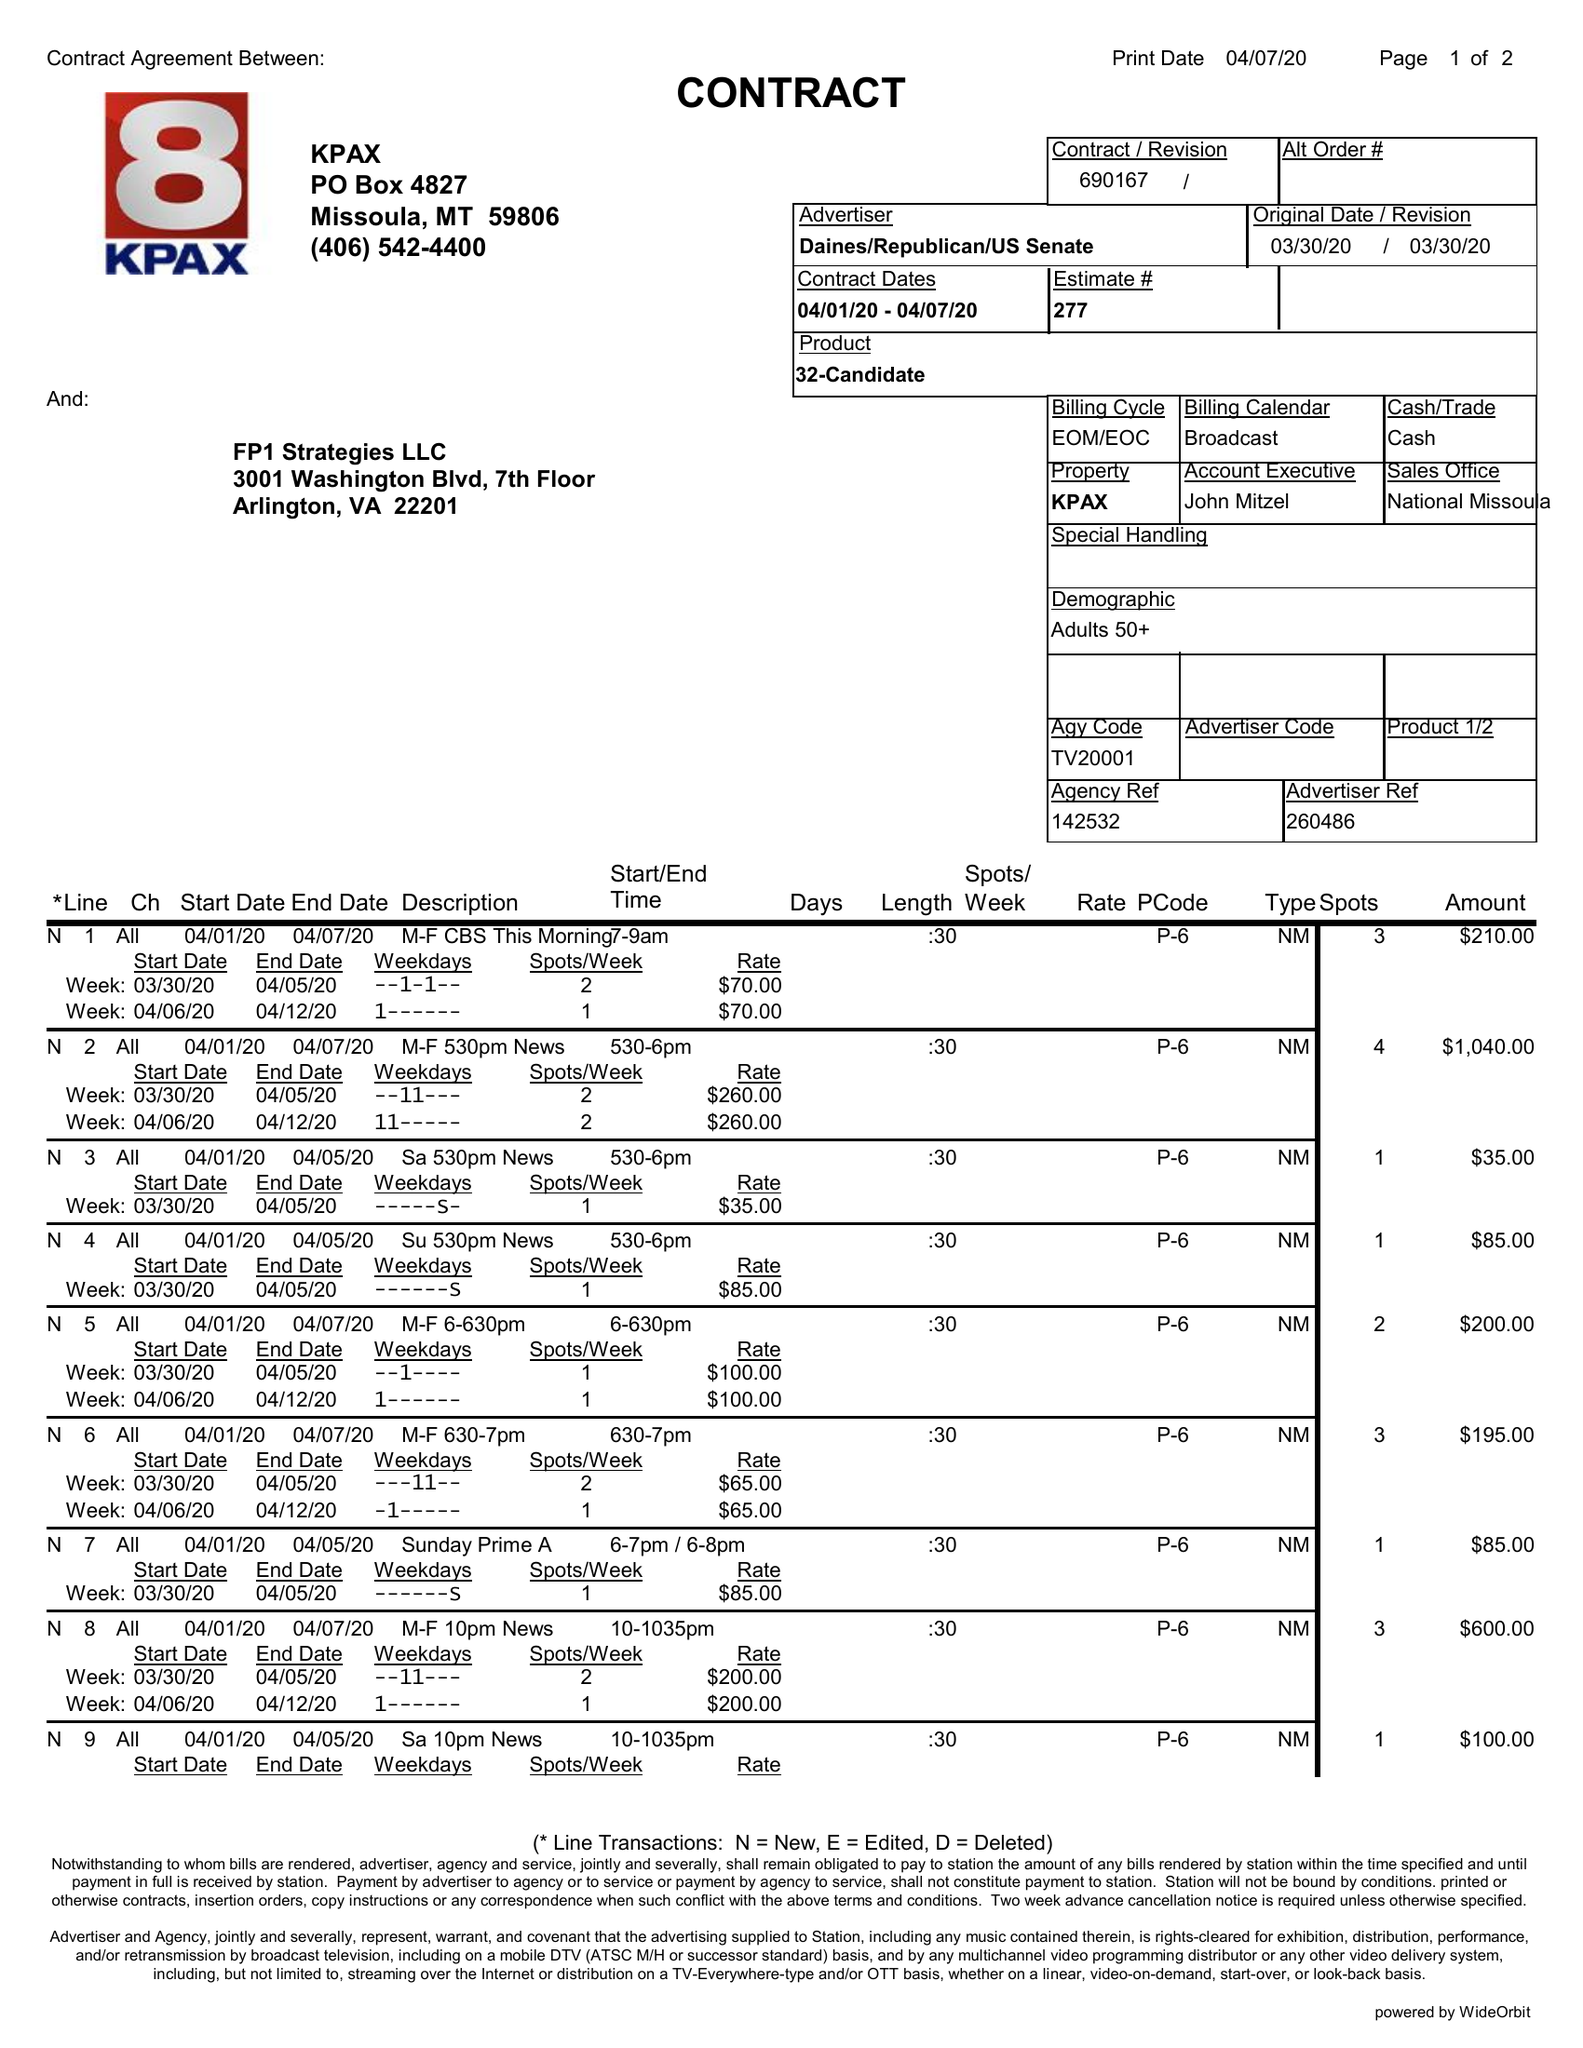What is the value for the contract_num?
Answer the question using a single word or phrase. 690167 